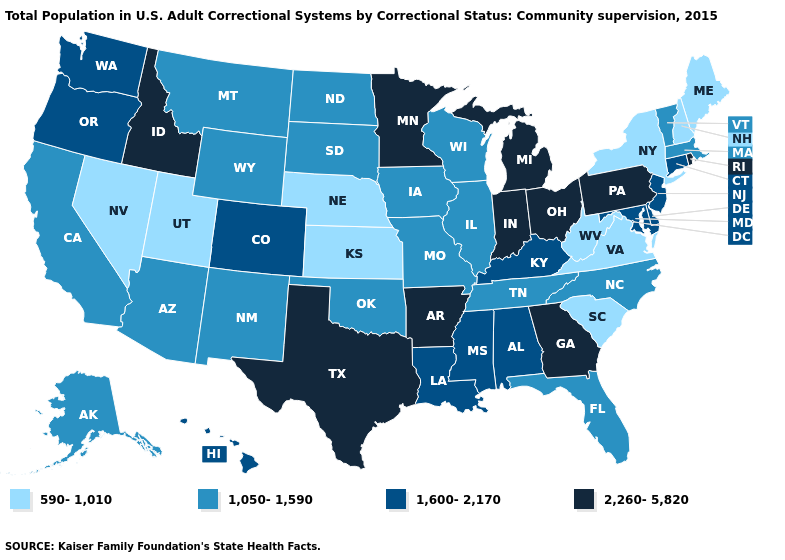Is the legend a continuous bar?
Answer briefly. No. Name the states that have a value in the range 1,050-1,590?
Be succinct. Alaska, Arizona, California, Florida, Illinois, Iowa, Massachusetts, Missouri, Montana, New Mexico, North Carolina, North Dakota, Oklahoma, South Dakota, Tennessee, Vermont, Wisconsin, Wyoming. What is the value of South Dakota?
Keep it brief. 1,050-1,590. What is the highest value in the MidWest ?
Concise answer only. 2,260-5,820. Among the states that border South Carolina , which have the lowest value?
Answer briefly. North Carolina. What is the lowest value in the USA?
Concise answer only. 590-1,010. Name the states that have a value in the range 1,050-1,590?
Write a very short answer. Alaska, Arizona, California, Florida, Illinois, Iowa, Massachusetts, Missouri, Montana, New Mexico, North Carolina, North Dakota, Oklahoma, South Dakota, Tennessee, Vermont, Wisconsin, Wyoming. Among the states that border Utah , which have the highest value?
Concise answer only. Idaho. What is the value of Rhode Island?
Write a very short answer. 2,260-5,820. Which states have the highest value in the USA?
Quick response, please. Arkansas, Georgia, Idaho, Indiana, Michigan, Minnesota, Ohio, Pennsylvania, Rhode Island, Texas. What is the value of Indiana?
Give a very brief answer. 2,260-5,820. Among the states that border Michigan , which have the highest value?
Give a very brief answer. Indiana, Ohio. Name the states that have a value in the range 2,260-5,820?
Concise answer only. Arkansas, Georgia, Idaho, Indiana, Michigan, Minnesota, Ohio, Pennsylvania, Rhode Island, Texas. Which states have the lowest value in the MidWest?
Concise answer only. Kansas, Nebraska. What is the lowest value in the USA?
Keep it brief. 590-1,010. 